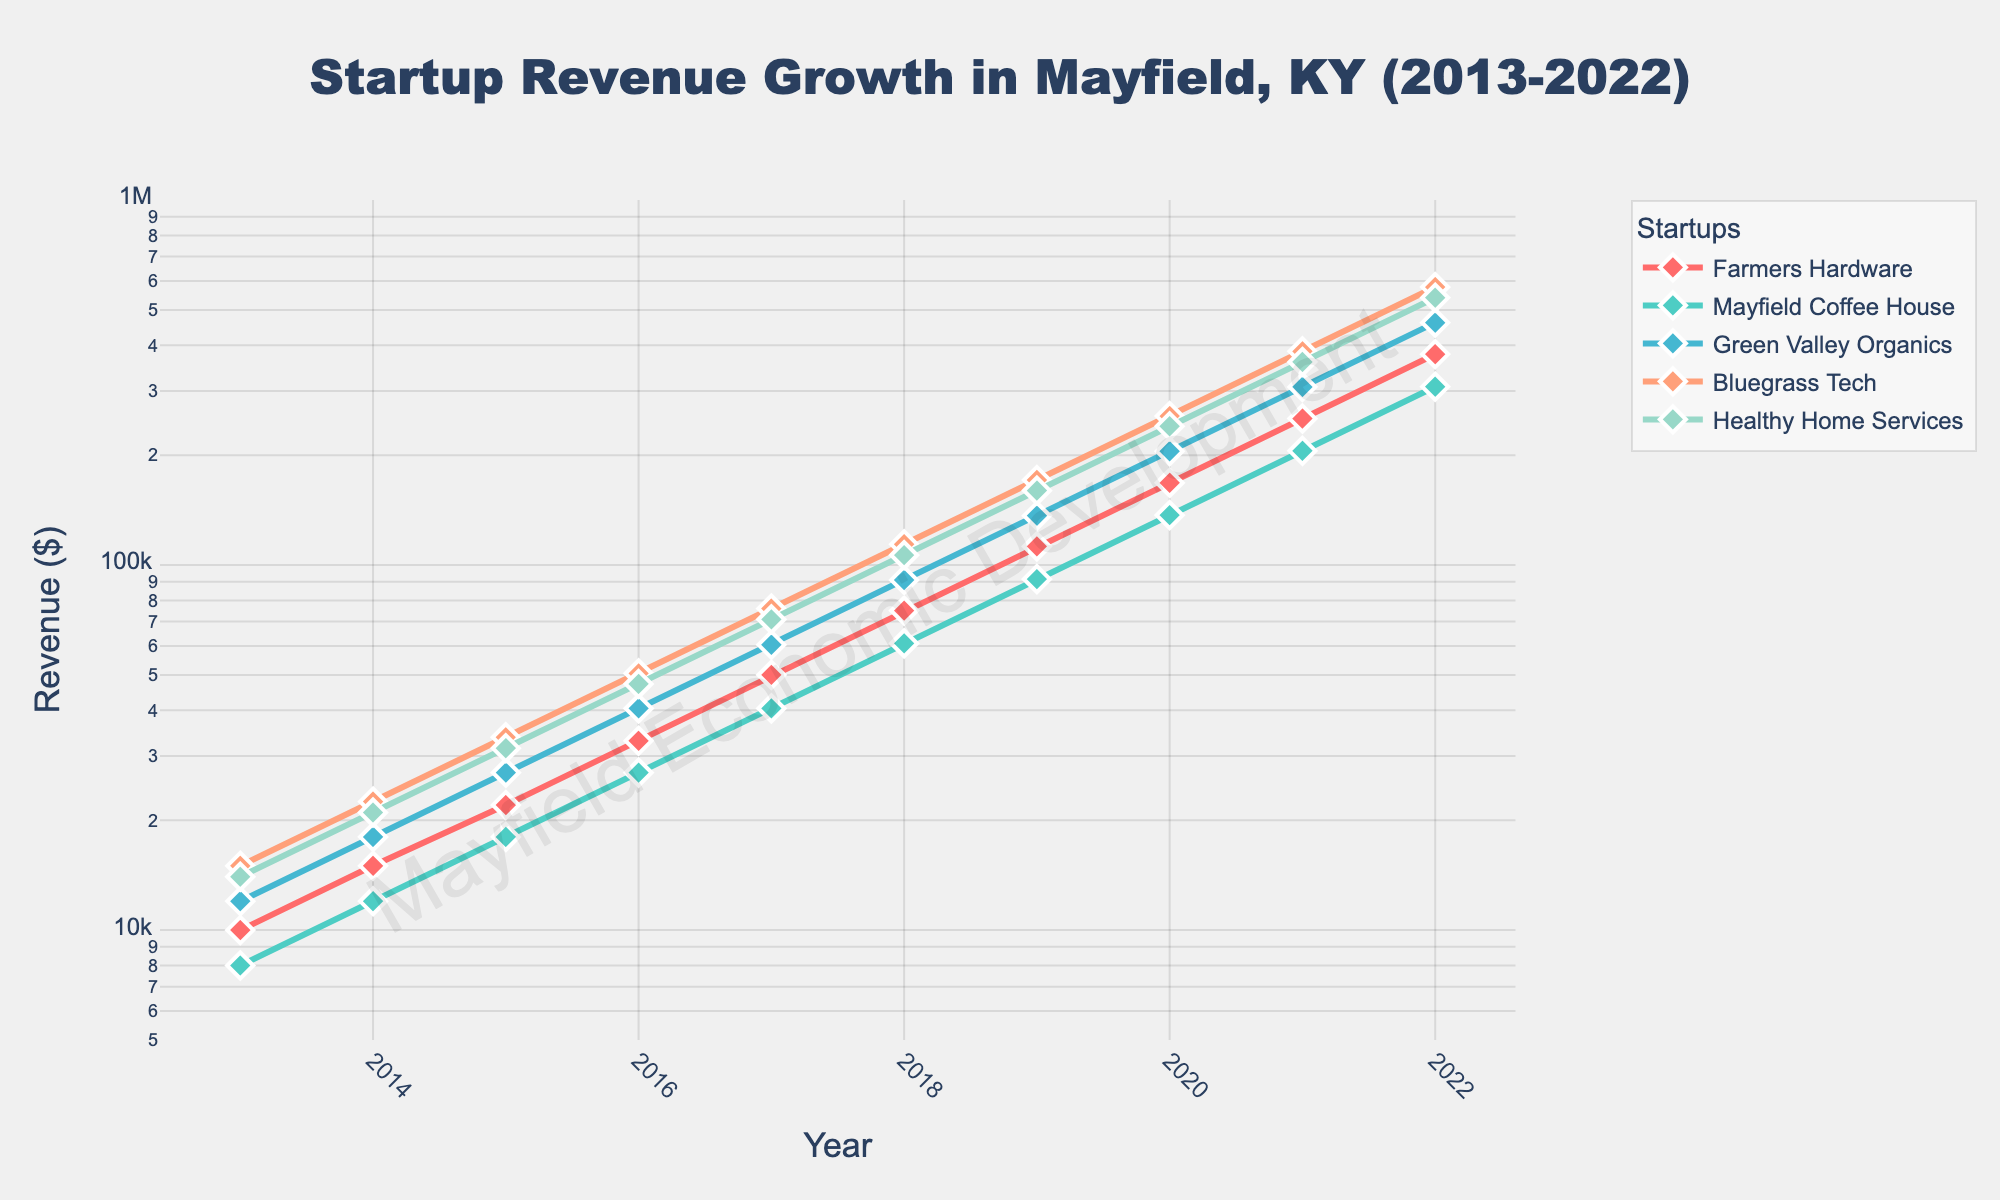What's the title of the figure? The title of the figure is usually prominently displayed at the top and describes the main subject of the plot. In this figure, the title reads "Startup Revenue Growth in Mayfield, KY (2013-2022)".
Answer: Startup Revenue Growth in Mayfield, KY (2013-2022) Which startup had the highest revenue in 2022? To determine which startup had the highest revenue in 2022, we look at the end of the lines on the plot for the year 2022 and see which one reaches the highest point on the y-axis. "Bluegrass Tech" appears to have the highest endpoint.
Answer: Bluegrass Tech How has the revenue for "Farmers Hardware" changed over the years? To assess the revenue change for "Farmers Hardware", we trace the line representing this startup from 2013 to 2022. The revenue increased exponentially from $10,000 in 2013 to $378,100 in 2022.
Answer: Increased exponentially What is the difference in revenue between "Green Valley Organics" and "Mayfield Coffee House" in 2016? First, find the revenues for both startups in 2016 from the plot. "Green Valley Organics" has a revenue of $40,500 and "Mayfield Coffee House" has a revenue of $27,000 in 2016. The difference is $40,500 - $27,000.
Answer: $13,500 Which startup had the most consistent revenue growth over the decade? To determine the most consistent growth, look for the line that shows a steady increase without any sharp spikes or dips. "Healthy Home Services" shows a very steady exponential growth over the decade.
Answer: Healthy Home Services What visual element indicates that this plot uses a log scale for the y-axis? The log scale can be identified by the non-linear spacing of the tick marks along the y-axis. The revenue values increase exponentially, which is evident from the y-axis labeling and distribution.
Answer: Non-linear spacing of tick marks How much did the revenue of "Mayfield Coffee House" increase from 2013 to 2022? Look at the revenue values for "Mayfield Coffee House" in 2013, which is $8,000, and in 2022, which is $308,000. The increase is calculated as $308,000 - $8,000.
Answer: $300,000 Compare the revenue growth rate of "Bluegrass Tech" and "Farmers Hardware". Which one grew faster over the decade? To compare the growth rate, look at the relative increase from 2013 to 2022. "Bluegrass Tech" increased from $15,000 to $577,500, whereas "Farmers Hardware" increased from $10,000 to $378,100. Calculating the growth multipliers, "Bluegrass Tech" grew by approximately 38.5 times (577,500 / 15,000), and "Farmers Hardware" grew by approximately 37.8 times (378,100 / 10,000). Thus, "Bluegrass Tech" grew slightly faster.
Answer: Bluegrass Tech 